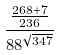<formula> <loc_0><loc_0><loc_500><loc_500>\frac { \frac { 2 6 8 + 7 } { 2 3 6 } } { 8 8 ^ { \sqrt { 3 4 7 } } }</formula> 